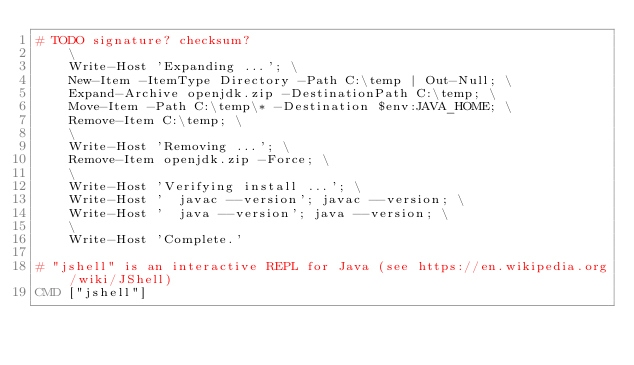<code> <loc_0><loc_0><loc_500><loc_500><_Dockerfile_># TODO signature? checksum?
	\
	Write-Host 'Expanding ...'; \
	New-Item -ItemType Directory -Path C:\temp | Out-Null; \
	Expand-Archive openjdk.zip -DestinationPath C:\temp; \
	Move-Item -Path C:\temp\* -Destination $env:JAVA_HOME; \
	Remove-Item C:\temp; \
	\
	Write-Host 'Removing ...'; \
	Remove-Item openjdk.zip -Force; \
	\
	Write-Host 'Verifying install ...'; \
	Write-Host '  javac --version'; javac --version; \
	Write-Host '  java --version'; java --version; \
	\
	Write-Host 'Complete.'

# "jshell" is an interactive REPL for Java (see https://en.wikipedia.org/wiki/JShell)
CMD ["jshell"]
</code> 